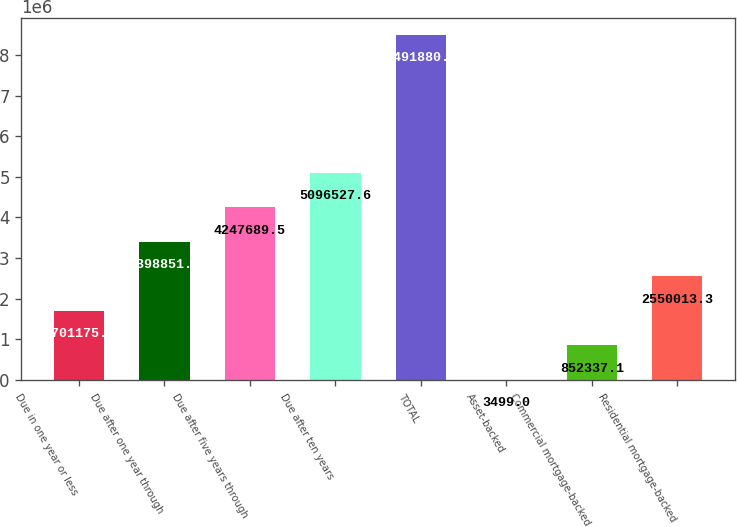Convert chart to OTSL. <chart><loc_0><loc_0><loc_500><loc_500><bar_chart><fcel>Due in one year or less<fcel>Due after one year through<fcel>Due after five years through<fcel>Due after ten years<fcel>TOTAL<fcel>Asset-backed<fcel>Commercial mortgage-backed<fcel>Residential mortgage-backed<nl><fcel>1.70118e+06<fcel>3.39885e+06<fcel>4.24769e+06<fcel>5.09653e+06<fcel>8.49188e+06<fcel>3499<fcel>852337<fcel>2.55001e+06<nl></chart> 